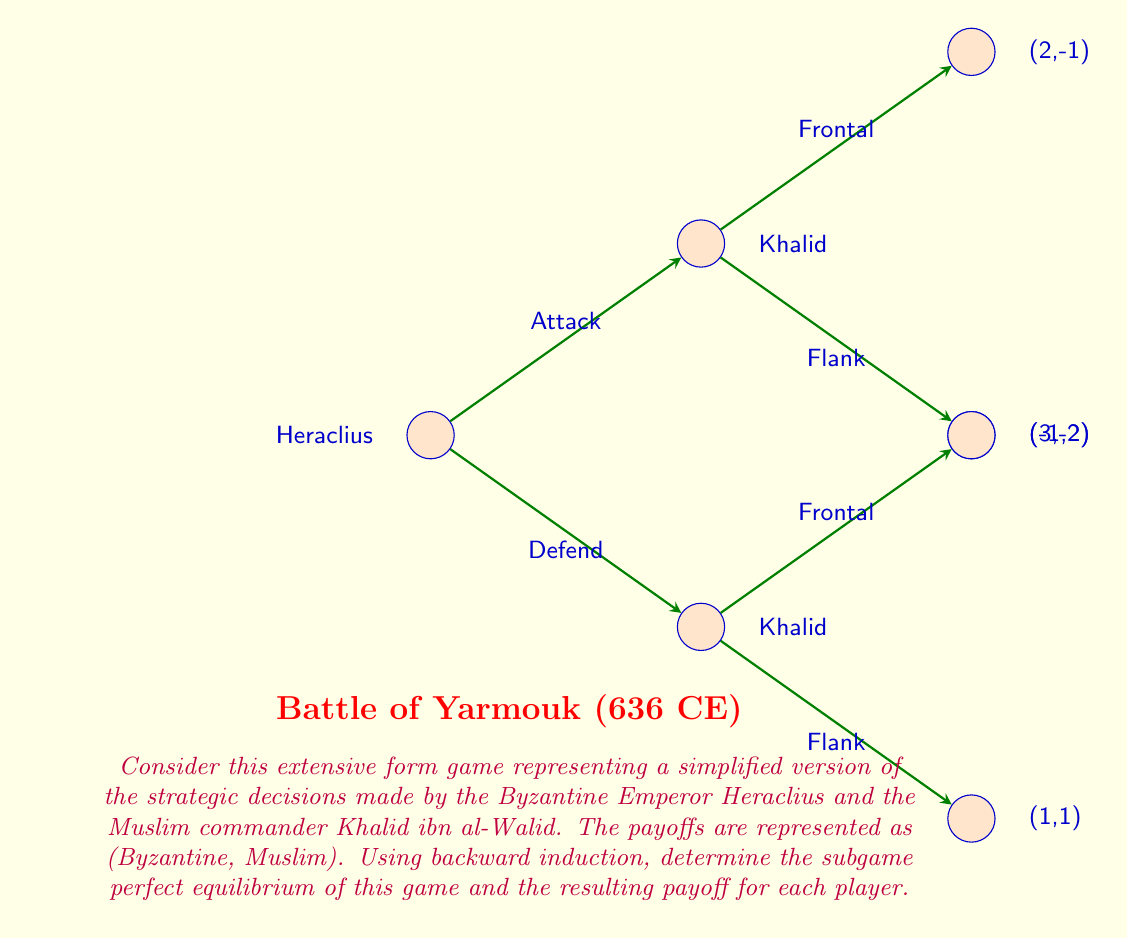Can you solve this math problem? To solve this extensive form game using backward induction, we'll start from the end and work our way back to the beginning:

1) First, consider Khalid's decisions:
   - If Heraclius attacks, Khalid chooses between:
     Frontal: (2,-1)
     Flank: (3,-2)
   Khalid would choose Frontal as -1 > -2.
   
   - If Heraclius defends, Khalid chooses between:
     Frontal: (-1,2)
     Flank: (1,1)
   Khalid would choose Frontal as 2 > 1.

2) Now, we can "prune" the tree, replacing Khalid's decision nodes with his optimal choices:

[asy]
unitsize(1cm);

// Nodes
dot((0,0));
dot((2,1));
dot((2,-1));
dot((4,1.5));
dot((4,-0.5));

// Lines
draw((0,0)--(2,1));
draw((0,0)--(2,-1));
draw((2,1)--(4,1.5));
draw((2,-1)--(4,-0.5));

// Labels
label("Heraclius", (-0.5,0), W);
label("Attack", (1,0.7), N);
label("Defend", (1,-0.7), S);
label("(2,-1)", (4.5,1.5), E);
label("(-1,2)", (4.5,-0.5), E);
[/asy]

3) Now, Heraclius chooses between:
   Attack: (2,-1)
   Defend: (-1,2)
   
   Heraclius would choose Attack as 2 > -1.

4) Therefore, the subgame perfect equilibrium is:
   - Heraclius chooses to Attack
   - If Heraclius Attacks, Khalid chooses Frontal
   - If Heraclius Defends, Khalid would have chosen Frontal (but this doesn't occur in equilibrium)

5) The resulting payoff is (2,-1), where 2 is Heraclius's payoff and -1 is Khalid's payoff.
Answer: Subgame Perfect Equilibrium: (Attack, Frontal); Payoff: (2,-1) 